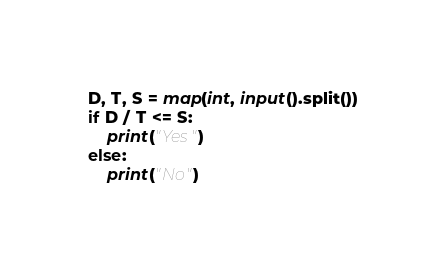<code> <loc_0><loc_0><loc_500><loc_500><_Python_>D, T, S = map(int, input().split())
if D / T <= S:
    print("Yes")
else:
    print("No")
</code> 